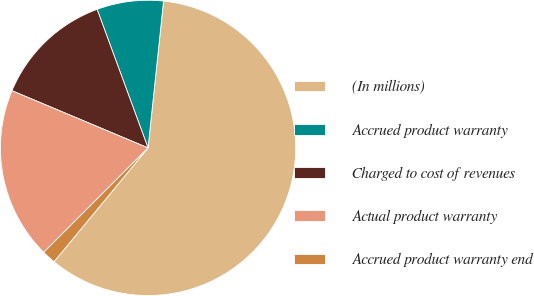Convert chart. <chart><loc_0><loc_0><loc_500><loc_500><pie_chart><fcel>(In millions)<fcel>Accrued product warranty<fcel>Charged to cost of revenues<fcel>Actual product warranty<fcel>Accrued product warranty end<nl><fcel>59.31%<fcel>7.28%<fcel>13.06%<fcel>18.84%<fcel>1.5%<nl></chart> 